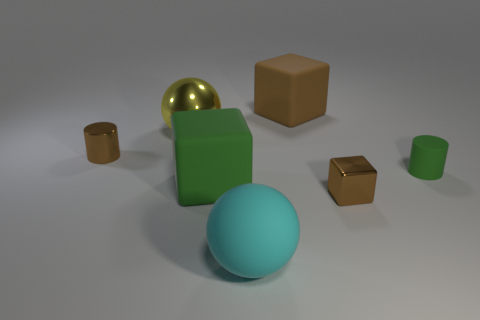Subtract all big cubes. How many cubes are left? 1 Add 3 yellow shiny things. How many objects exist? 10 Subtract 1 cylinders. How many cylinders are left? 1 Subtract all red cylinders. Subtract all blue spheres. How many cylinders are left? 2 Subtract all gray balls. How many blue cylinders are left? 0 Subtract all purple shiny cylinders. Subtract all tiny brown cylinders. How many objects are left? 6 Add 5 big brown blocks. How many big brown blocks are left? 6 Add 4 big red rubber objects. How many big red rubber objects exist? 4 Subtract all brown cylinders. How many cylinders are left? 1 Subtract 0 purple spheres. How many objects are left? 7 